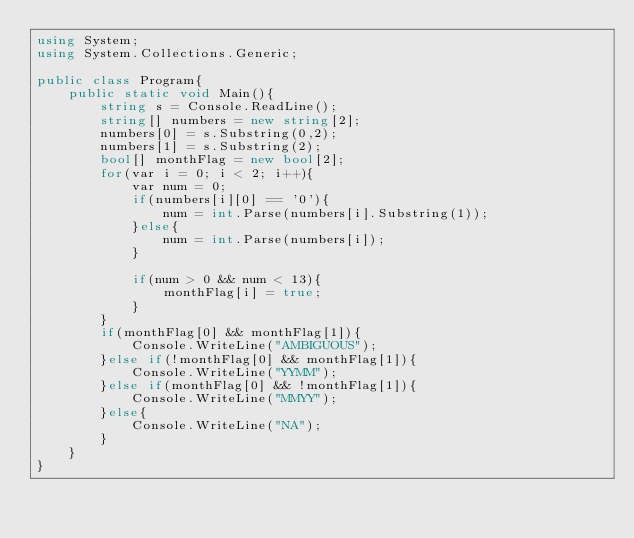Convert code to text. <code><loc_0><loc_0><loc_500><loc_500><_C#_>using System;
using System.Collections.Generic;

public class Program{
    public static void Main(){
        string s = Console.ReadLine();
        string[] numbers = new string[2];
        numbers[0] = s.Substring(0,2);
        numbers[1] = s.Substring(2);
        bool[] monthFlag = new bool[2];
        for(var i = 0; i < 2; i++){
            var num = 0;
            if(numbers[i][0] == '0'){
                num = int.Parse(numbers[i].Substring(1));
            }else{
                num = int.Parse(numbers[i]);
            }
            
            if(num > 0 && num < 13){
                monthFlag[i] = true;
            }
        }
        if(monthFlag[0] && monthFlag[1]){
            Console.WriteLine("AMBIGUOUS");
        }else if(!monthFlag[0] && monthFlag[1]){
            Console.WriteLine("YYMM");
        }else if(monthFlag[0] && !monthFlag[1]){
            Console.WriteLine("MMYY");
        }else{
            Console.WriteLine("NA");
        }
    }
}
</code> 